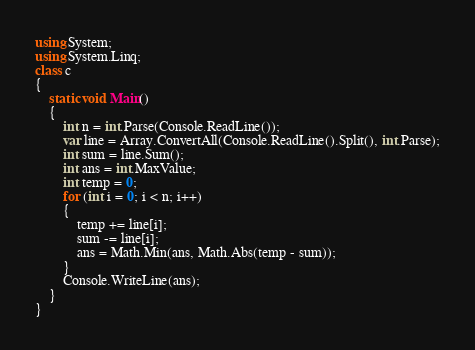<code> <loc_0><loc_0><loc_500><loc_500><_C#_>using System;
using System.Linq;
class c
{
    static void Main()
    {
        int n = int.Parse(Console.ReadLine());
        var line = Array.ConvertAll(Console.ReadLine().Split(), int.Parse);
        int sum = line.Sum();
        int ans = int.MaxValue;
        int temp = 0;
        for (int i = 0; i < n; i++)
        {
            temp += line[i];
            sum -= line[i];
            ans = Math.Min(ans, Math.Abs(temp - sum));
        }
        Console.WriteLine(ans);
    }
}</code> 